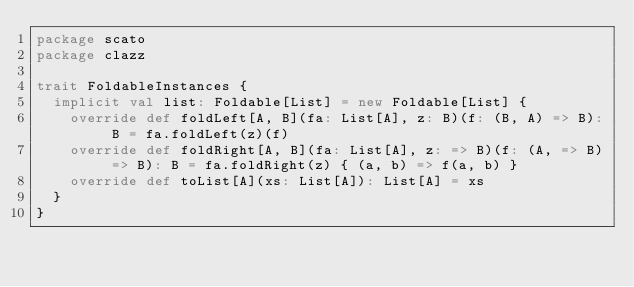Convert code to text. <code><loc_0><loc_0><loc_500><loc_500><_Scala_>package scato
package clazz

trait FoldableInstances {
  implicit val list: Foldable[List] = new Foldable[List] {
    override def foldLeft[A, B](fa: List[A], z: B)(f: (B, A) => B): B = fa.foldLeft(z)(f)
    override def foldRight[A, B](fa: List[A], z: => B)(f: (A, => B) => B): B = fa.foldRight(z) { (a, b) => f(a, b) }
    override def toList[A](xs: List[A]): List[A] = xs
  }
}

</code> 